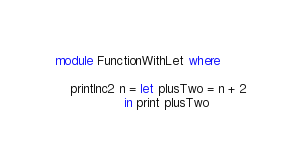<code> <loc_0><loc_0><loc_500><loc_500><_Haskell_>module FunctionWithLet where

    printInc2 n = let plusTwo = n + 2
                  in print plusTwo
</code> 